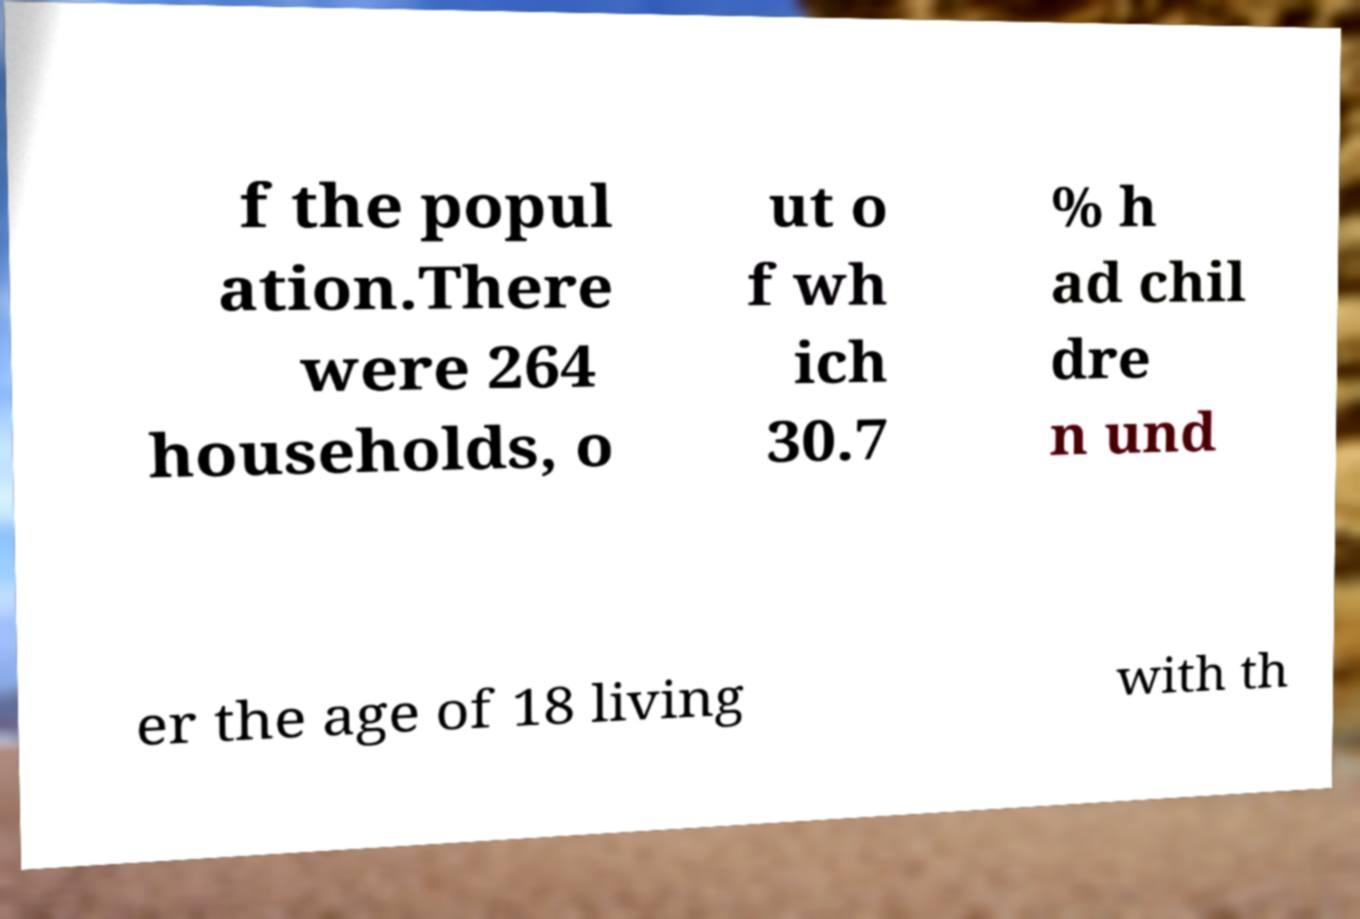Please read and relay the text visible in this image. What does it say? f the popul ation.There were 264 households, o ut o f wh ich 30.7 % h ad chil dre n und er the age of 18 living with th 